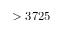Convert formula to latex. <formula><loc_0><loc_0><loc_500><loc_500>> 3 7 2 5</formula> 